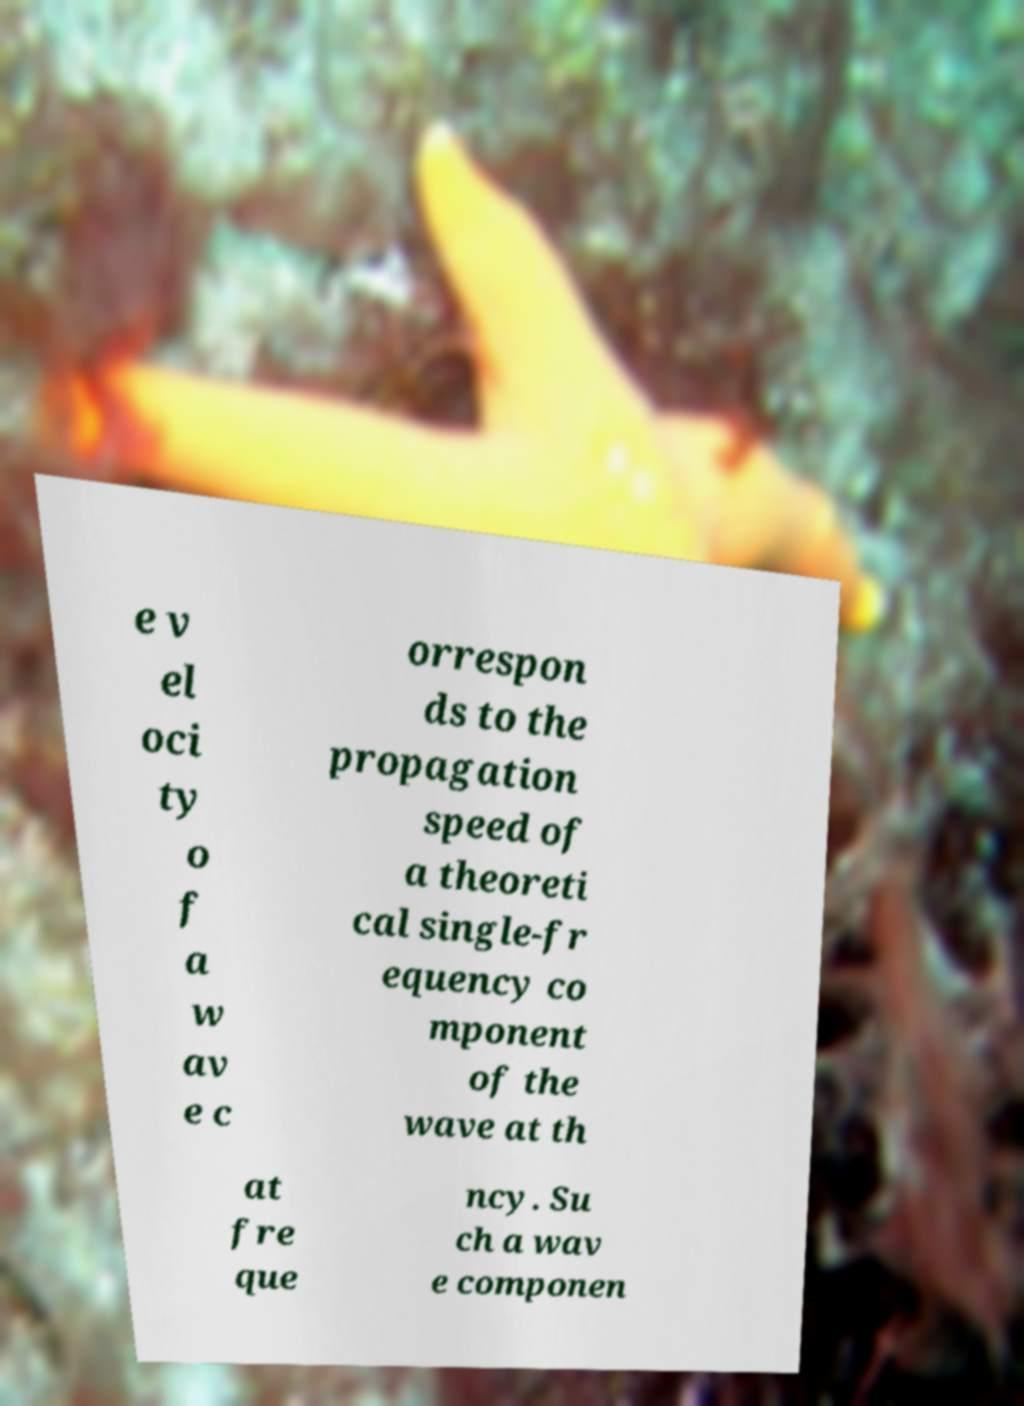Can you read and provide the text displayed in the image?This photo seems to have some interesting text. Can you extract and type it out for me? e v el oci ty o f a w av e c orrespon ds to the propagation speed of a theoreti cal single-fr equency co mponent of the wave at th at fre que ncy. Su ch a wav e componen 